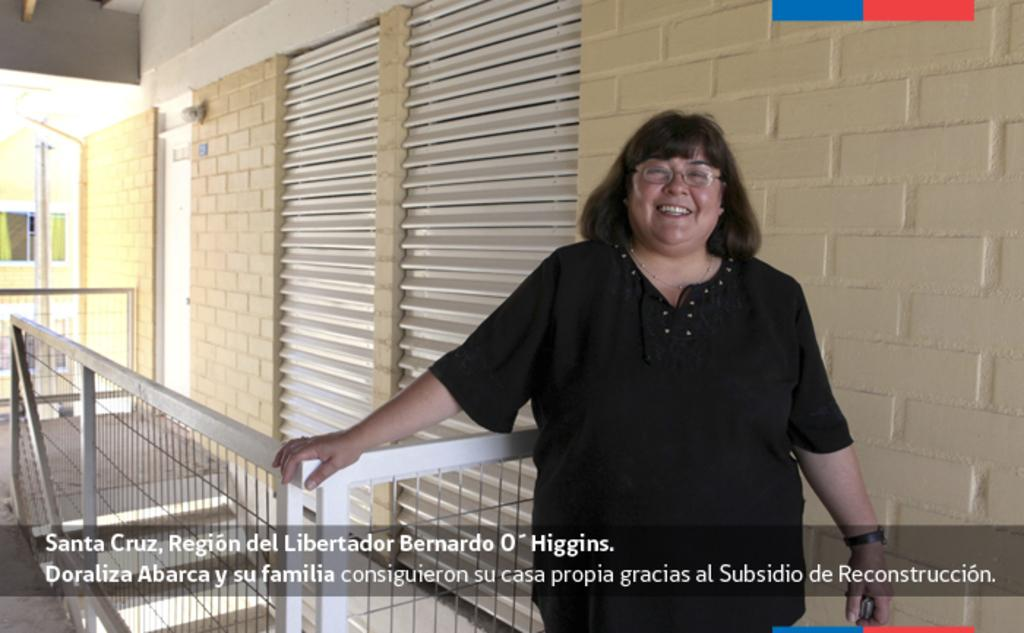What is the main subject of the image? There is a woman standing in the image. Where is the woman located in relation to the railing? The woman is near a railing in the image. What can be seen in the background of the image? There is a wall with shutters in the background of the image. Is there any entrance visible in the image? Yes, there is a door on the wall in the image. What type of flower can be seen growing near the door in the image? There is no flower visible near the door in the image. 